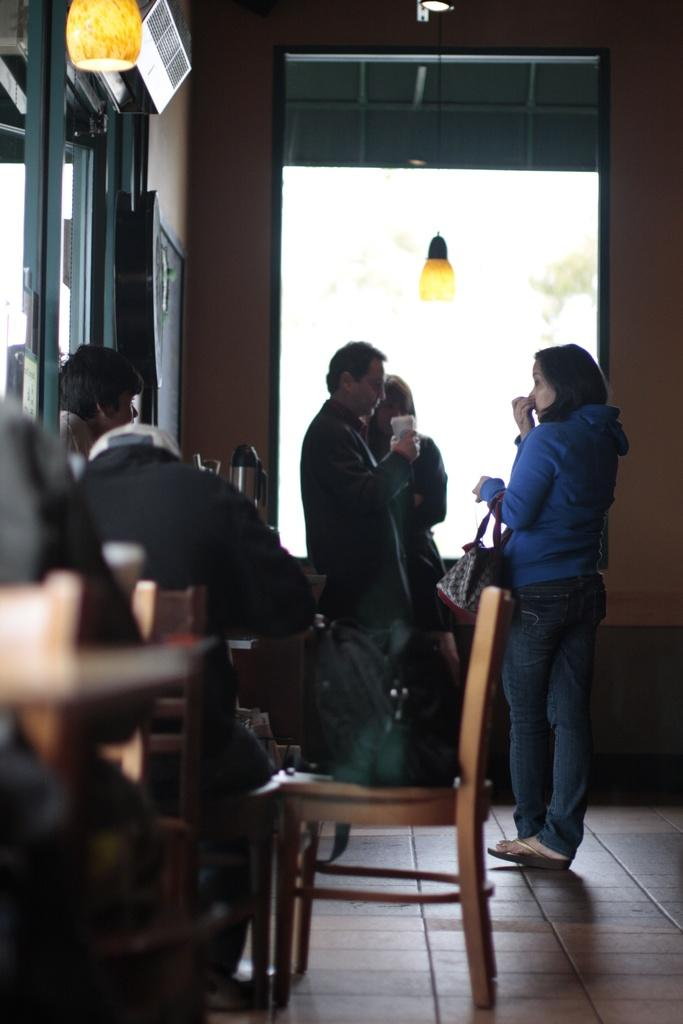How many people are standing near the window in the image? There are three people standing near the window in the image. What is the other person in the image doing? The other person is looking at them. What can be seen on the chair in the image? There is a backpack on the chair. What is on the roof in the image? There are lamps on the roof. What book is the person reading in the image? There is no person reading a book in the image. What type of mark can be seen on the backpack? There is no mark visible on the backpack in the image. 